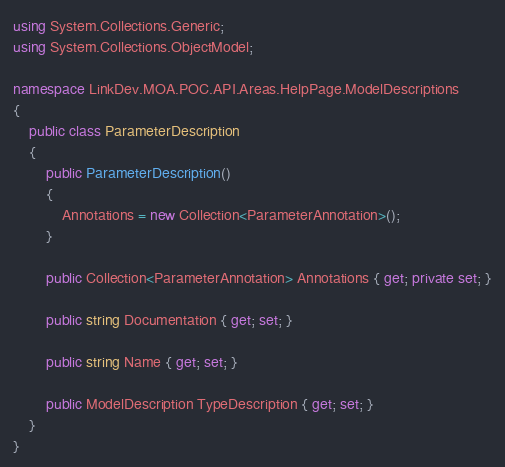<code> <loc_0><loc_0><loc_500><loc_500><_C#_>using System.Collections.Generic;
using System.Collections.ObjectModel;

namespace LinkDev.MOA.POC.API.Areas.HelpPage.ModelDescriptions
{
    public class ParameterDescription
    {
        public ParameterDescription()
        {
            Annotations = new Collection<ParameterAnnotation>();
        }

        public Collection<ParameterAnnotation> Annotations { get; private set; }

        public string Documentation { get; set; }

        public string Name { get; set; }

        public ModelDescription TypeDescription { get; set; }
    }
}</code> 